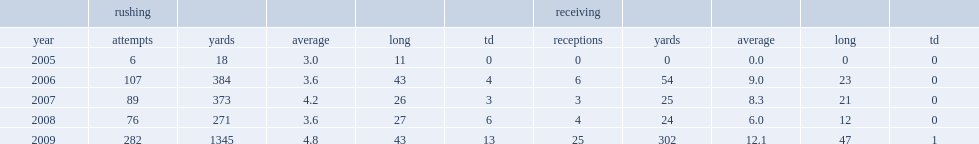How many carriers did hardesty have in 2009? 282.0. Write the full table. {'header': ['', 'rushing', '', '', '', '', 'receiving', '', '', '', ''], 'rows': [['year', 'attempts', 'yards', 'average', 'long', 'td', 'receptions', 'yards', 'average', 'long', 'td'], ['2005', '6', '18', '3.0', '11', '0', '0', '0', '0.0', '0', '0'], ['2006', '107', '384', '3.6', '43', '4', '6', '54', '9.0', '23', '0'], ['2007', '89', '373', '4.2', '26', '3', '3', '25', '8.3', '21', '0'], ['2008', '76', '271', '3.6', '27', '6', '4', '24', '6.0', '12', '0'], ['2009', '282', '1345', '4.8', '43', '13', '25', '302', '12.1', '47', '1']]} 